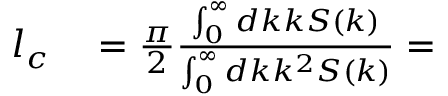<formula> <loc_0><loc_0><loc_500><loc_500>\begin{array} { r l } { l _ { c } } & = \frac { \pi } { 2 } \frac { \int _ { 0 } ^ { \infty } d k k S ( k ) } { \int _ { 0 } ^ { \infty } d k k ^ { 2 } S ( k ) } = } \end{array}</formula> 